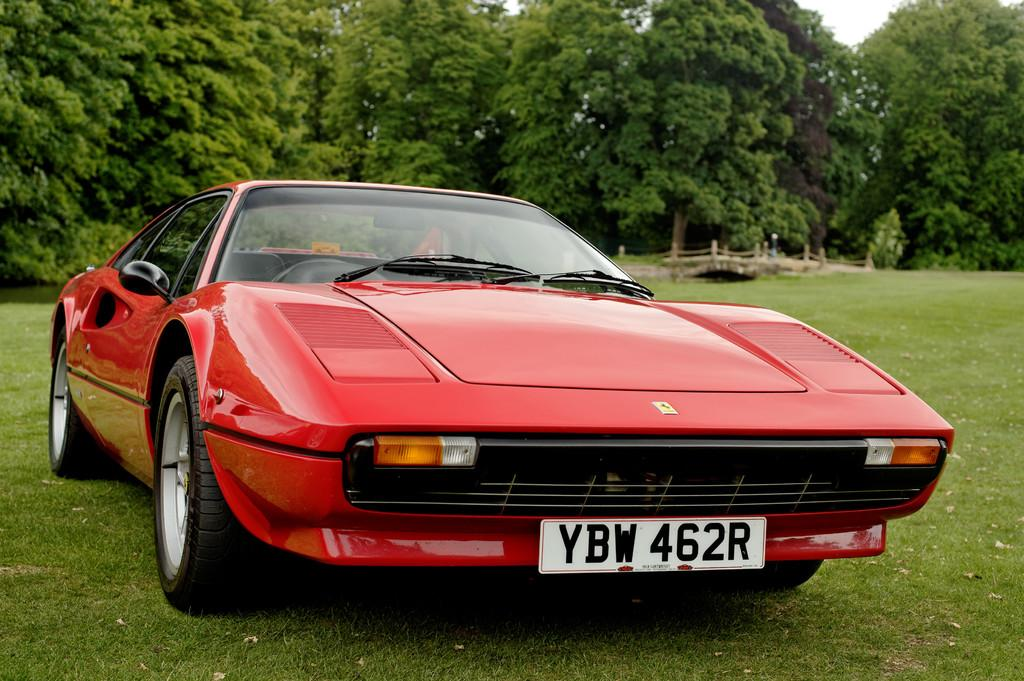What type of vehicle is in the image? There is a red car in the image. Where is the car located? The car is on the grassland. What can be seen in the background of the image? There are trees visible in the background of the image. How many goldfish are swimming in the car's gas tank in the image? There are no goldfish present in the image, and the car's gas tank is not visible. 